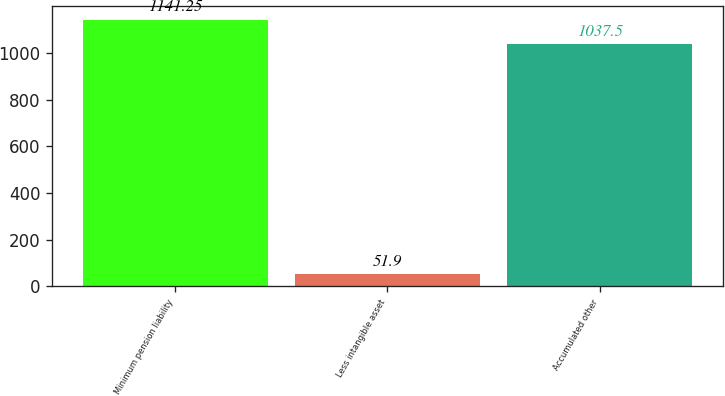Convert chart. <chart><loc_0><loc_0><loc_500><loc_500><bar_chart><fcel>Minimum pension liability<fcel>Less intangible asset<fcel>Accumulated other<nl><fcel>1141.25<fcel>51.9<fcel>1037.5<nl></chart> 